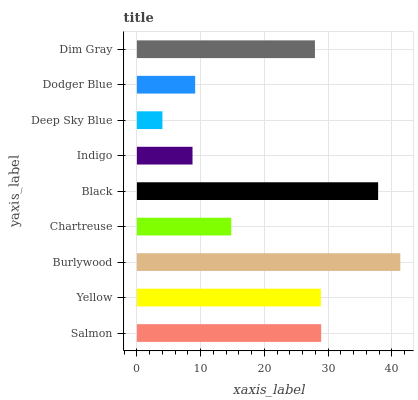Is Deep Sky Blue the minimum?
Answer yes or no. Yes. Is Burlywood the maximum?
Answer yes or no. Yes. Is Yellow the minimum?
Answer yes or no. No. Is Yellow the maximum?
Answer yes or no. No. Is Salmon greater than Yellow?
Answer yes or no. Yes. Is Yellow less than Salmon?
Answer yes or no. Yes. Is Yellow greater than Salmon?
Answer yes or no. No. Is Salmon less than Yellow?
Answer yes or no. No. Is Dim Gray the high median?
Answer yes or no. Yes. Is Dim Gray the low median?
Answer yes or no. Yes. Is Black the high median?
Answer yes or no. No. Is Deep Sky Blue the low median?
Answer yes or no. No. 